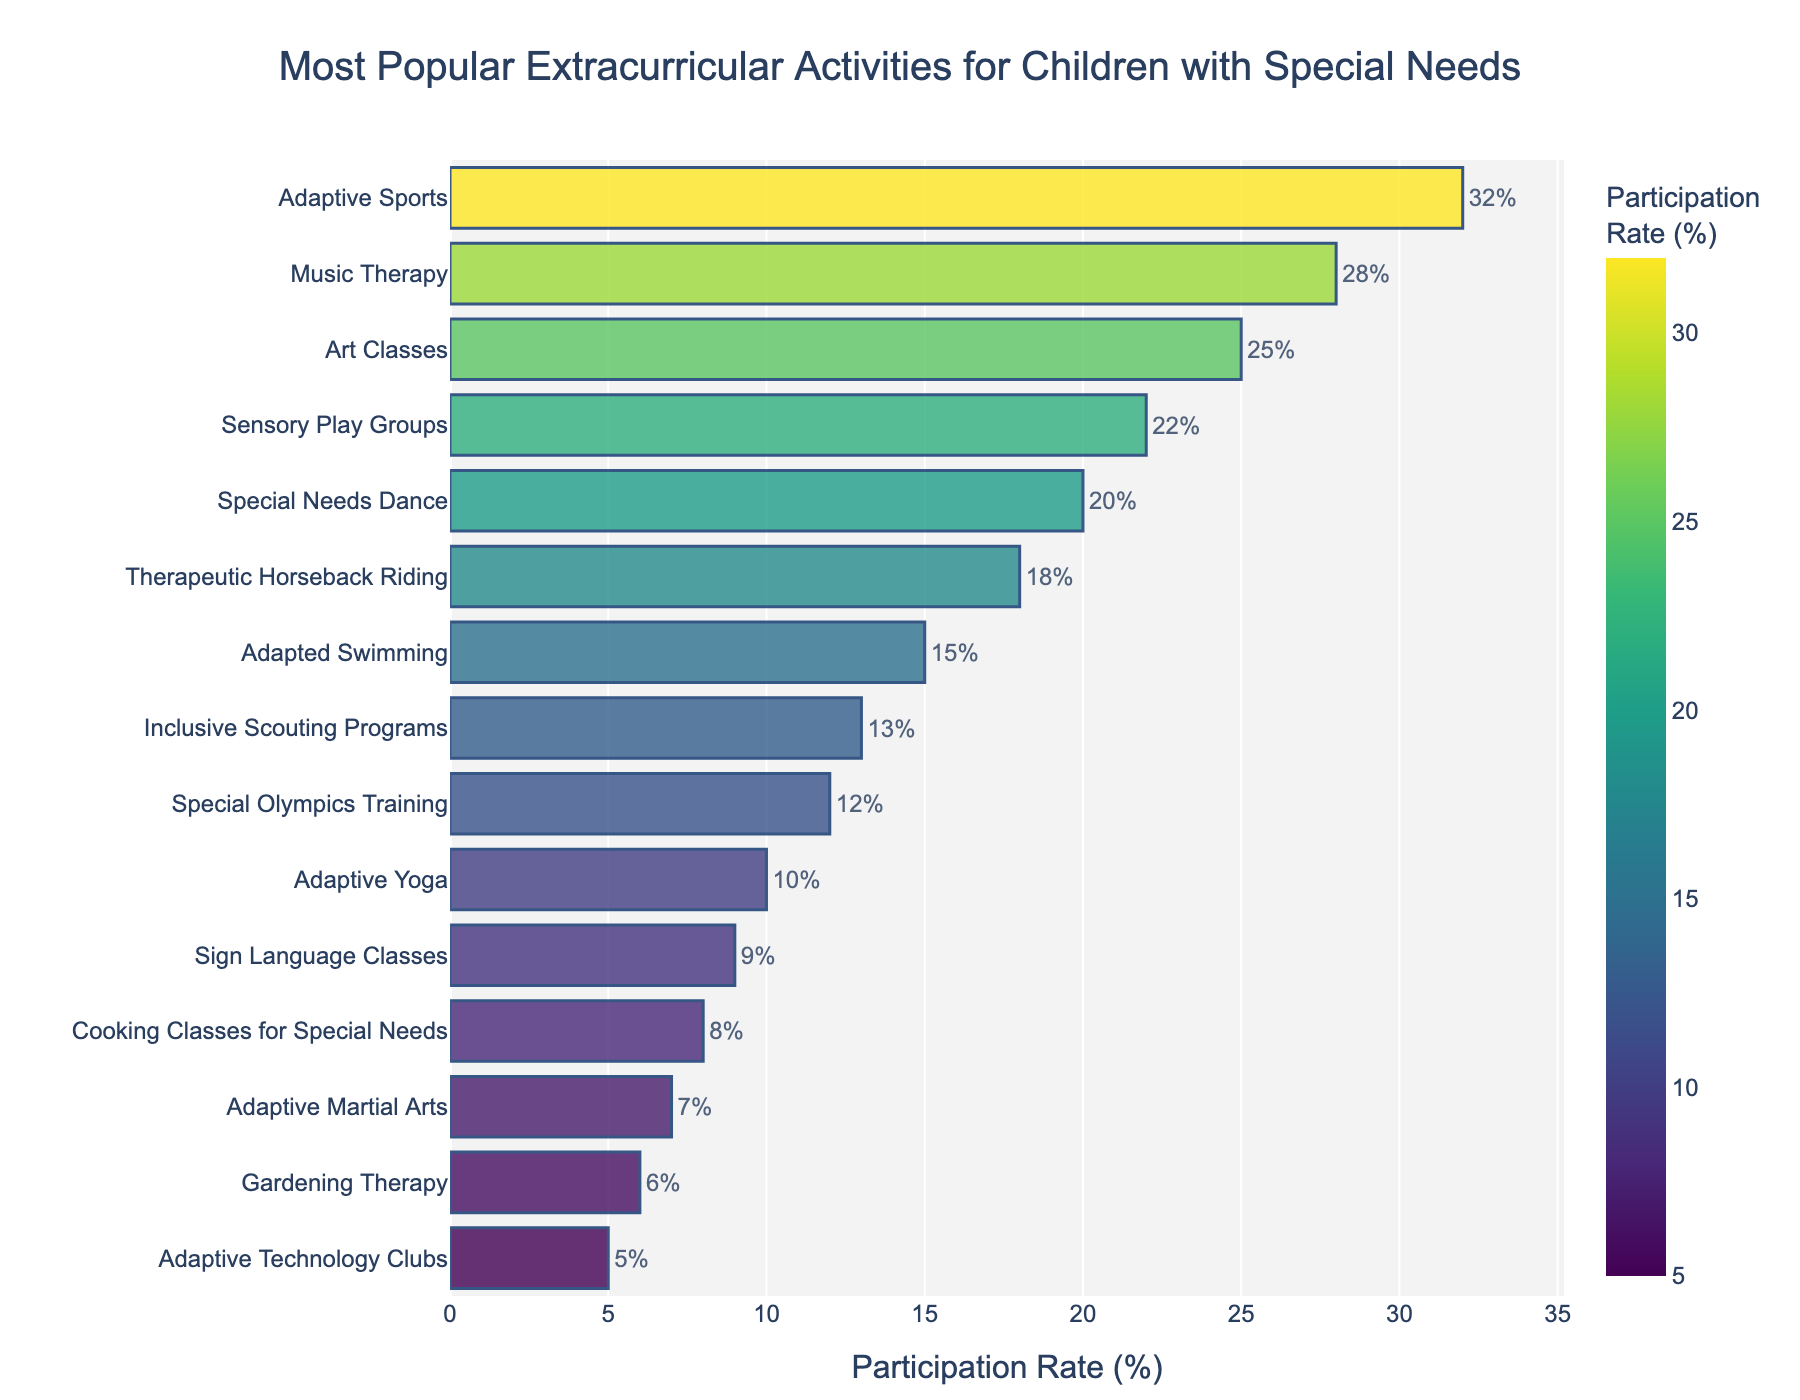Which activity has the highest participation rate? The highest bar represents the activity with the highest participation rate. In this chart, the "Adaptive Sports" bar is the longest and reaches 32%.
Answer: Adaptive Sports Which two activities have the smallest difference in participation rates? To find the smallest difference, we look for bars that are close in length. We see that "Special Olympics Training" at 12% and "Adaptive Yoga" at 10% have a difference of 2%.
Answer: Special Olympics Training and Adaptive Yoga What's the combined participation rate for the top three activities? The top three activities by length of their bars are "Adaptive Sports" (32%), "Music Therapy" (28%), and "Art Classes" (25%). Adding these, 32% + 28% + 25% = 85%.
Answer: 85% How much higher is the participation rate for "Sensory Play Groups" compared to "Inclusive Scouting Programs"? "Sensory Play Groups" has a 22% participation rate, while "Inclusive Scouting Programs" has 13%. The difference is 22% - 13% = 9%.
Answer: 9% Which activity has a participation rate of 15%? Read the labels next to the bars to find the activity with a 15% participation rate. "Adapted Swimming" is the activity with a 15% rate.
Answer: Adapted Swimming Of the listed activities, how many have a participation rate of less than 10%? Look for bars where the participation rate label reads below 10%. These activities are: "Sign Language Classes" (9%), "Cooking Classes for Special Needs" (8%), "Adaptive Martial Arts" (7%), "Gardening Therapy" (6%), and "Adaptive Technology Clubs" (5%). There are 5 activities in total.
Answer: 5 How does the participation rate of "Therapeutic Horseback Riding" compare to "Adaptive Martial Arts"? "Therapeutic Horseback Riding" has a 18% participation rate, whereas "Adaptive Martial Arts" has a 7% participation rate. Therefore, Therapeutic Horseback Riding has a higher participation rate.
Answer: Therapeutic Horseback Riding is higher 